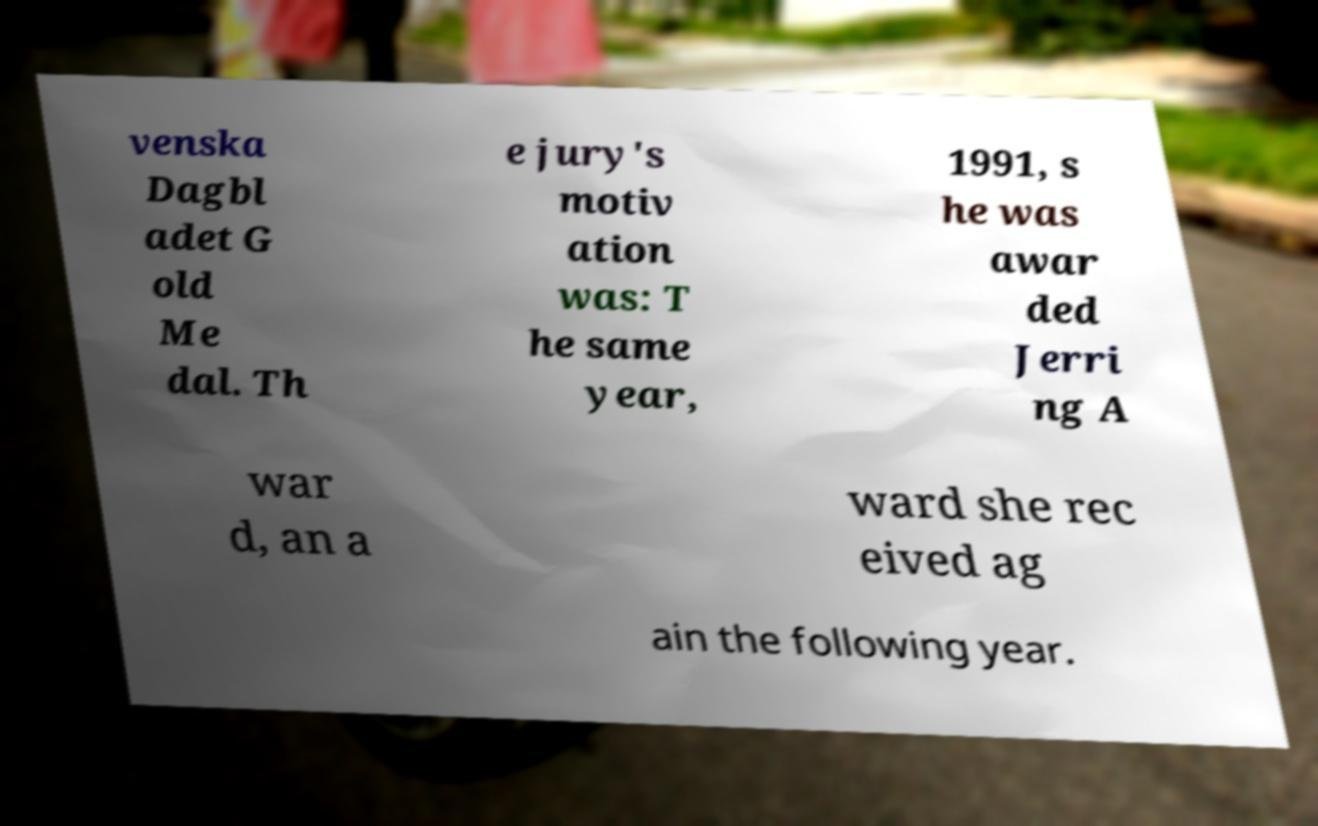For documentation purposes, I need the text within this image transcribed. Could you provide that? venska Dagbl adet G old Me dal. Th e jury's motiv ation was: T he same year, 1991, s he was awar ded Jerri ng A war d, an a ward she rec eived ag ain the following year. 